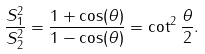Convert formula to latex. <formula><loc_0><loc_0><loc_500><loc_500>\frac { S _ { 1 } ^ { 2 } } { S _ { 2 } ^ { 2 } } = \frac { 1 + \cos ( \theta ) } { 1 - \cos ( \theta ) } = \cot ^ { 2 } \frac { \theta } { 2 } .</formula> 